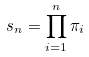<formula> <loc_0><loc_0><loc_500><loc_500>s _ { n } = \prod _ { i = 1 } ^ { n } \pi _ { i }</formula> 